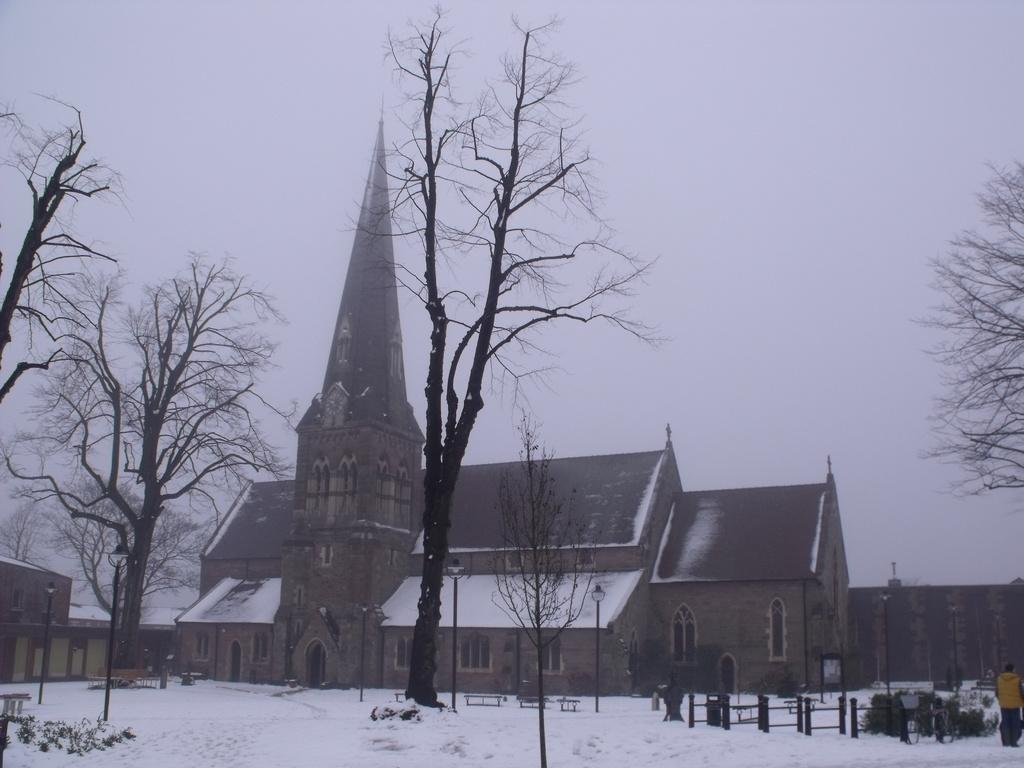How many people can be seen in the image? There are people in the image, but the exact number is not specified. What type of structure is present in the image? There is a fence in the image. What are the tall, vertical structures with wires in the image? Electric poles are visible in the image. What type of seating is available in the image? There are benches in the image. What type of vegetation is present in the image? Trees are present in the image. What is the weather like in the image? There is snow in the image, indicating a cold or wintery environment. What objects can be found on the ground in the image? There are objects on the ground in the image, but their specific nature is not mentioned. What can be seen in the background of the image? There are buildings and the sky visible in the background of the image. How many elbows can be seen on the people in the image? The number of elbows cannot be determined from the image, as it does not provide a clear view of the people's arms or positions. What type of salt is used to decorate the trees in the image? There is no salt present in the image, as it features snow and not salt. 